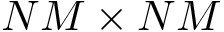<formula> <loc_0><loc_0><loc_500><loc_500>N M \times N M</formula> 